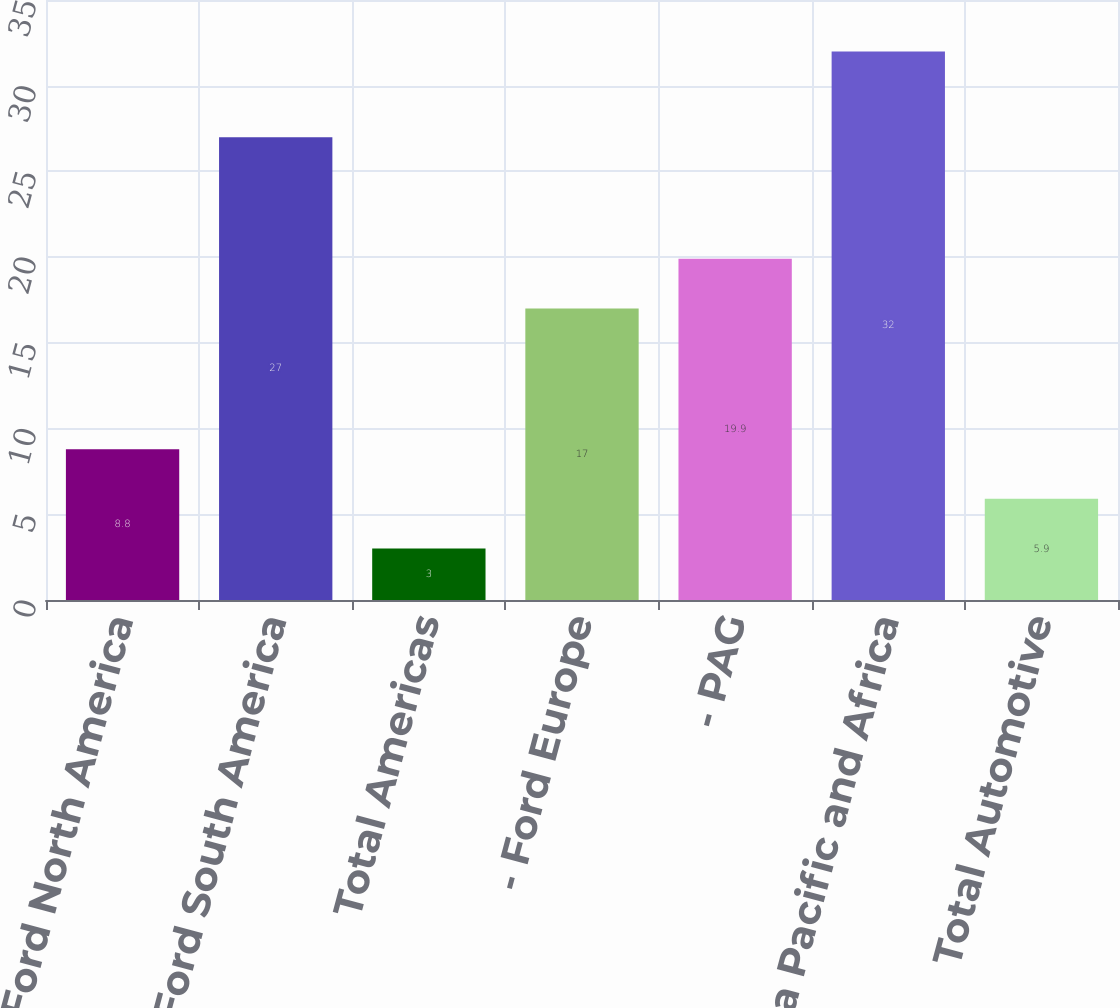Convert chart to OTSL. <chart><loc_0><loc_0><loc_500><loc_500><bar_chart><fcel>- Ford North America<fcel>- Ford South America<fcel>Total Americas<fcel>- Ford Europe<fcel>- PAG<fcel>Ford Asia Pacific and Africa<fcel>Total Automotive<nl><fcel>8.8<fcel>27<fcel>3<fcel>17<fcel>19.9<fcel>32<fcel>5.9<nl></chart> 